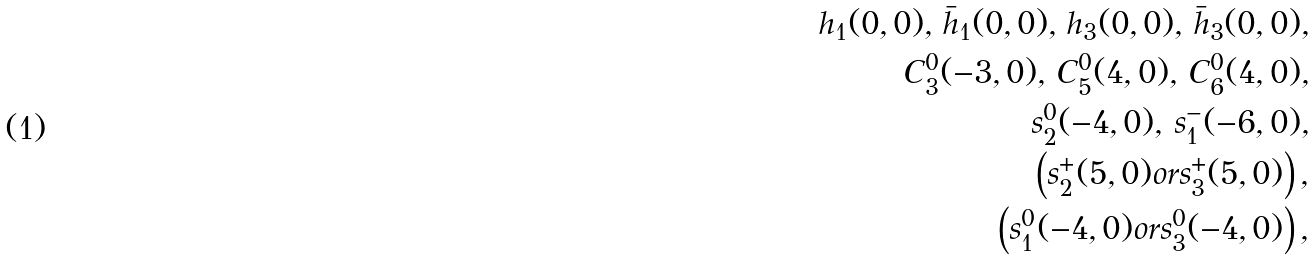Convert formula to latex. <formula><loc_0><loc_0><loc_500><loc_500>h _ { 1 } ( 0 , 0 ) , \, \bar { h } _ { 1 } ( 0 , 0 ) , \, h _ { 3 } ( 0 , 0 ) , \, \bar { h } _ { 3 } ( 0 , 0 ) , \\ C ^ { 0 } _ { 3 } ( - 3 , 0 ) , \, C _ { 5 } ^ { 0 } ( 4 , 0 ) , \, C _ { 6 } ^ { 0 } ( 4 , 0 ) , \\ s ^ { 0 } _ { 2 } ( - 4 , 0 ) , \, s ^ { - } _ { 1 } ( - 6 , 0 ) , \\ \left ( s ^ { + } _ { 2 } ( 5 , 0 ) o r s ^ { + } _ { 3 } ( 5 , 0 ) \right ) , \\ \left ( s ^ { 0 } _ { 1 } ( - 4 , 0 ) o r s ^ { 0 } _ { 3 } ( - 4 , 0 ) \right ) ,</formula> 